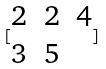<formula> <loc_0><loc_0><loc_500><loc_500>[ \begin{matrix} 2 & 2 & 4 \\ 3 & 5 \end{matrix} ]</formula> 